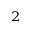<formula> <loc_0><loc_0><loc_500><loc_500>_ { 2 }</formula> 